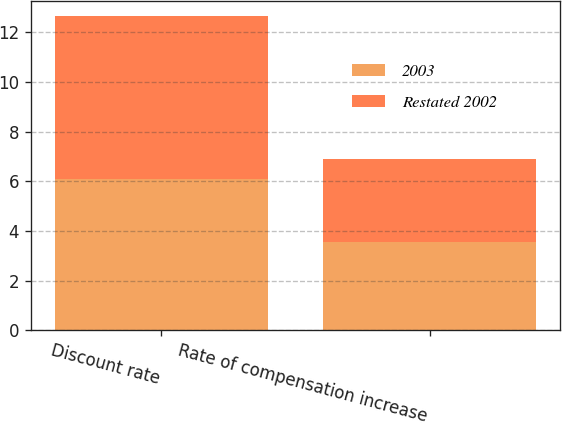Convert chart to OTSL. <chart><loc_0><loc_0><loc_500><loc_500><stacked_bar_chart><ecel><fcel>Discount rate<fcel>Rate of compensation increase<nl><fcel>2003<fcel>6.08<fcel>3.57<nl><fcel>Restated 2002<fcel>6.56<fcel>3.33<nl></chart> 